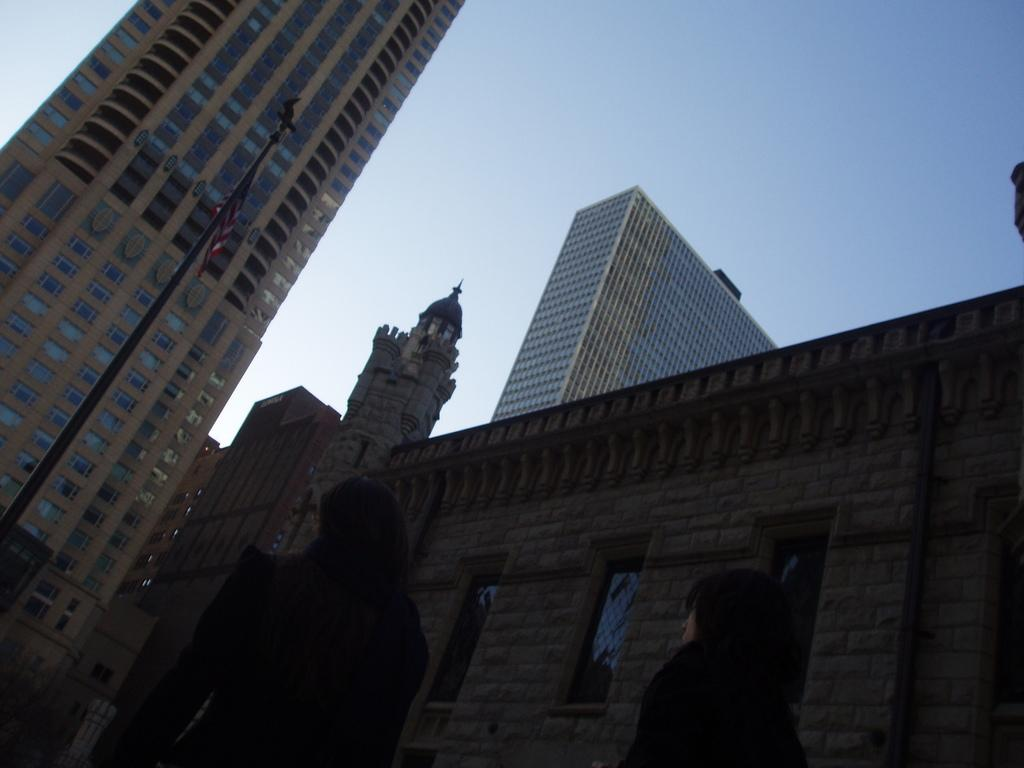What is the main subject of the image? The main subject of the image is the buildings in the center. Can you describe the buildings in the center? Unfortunately, the provided facts do not give any details about the buildings in the center. What other notable structure can be seen in the image? There is a skyscraper on the left side of the image. How many people are sitting on the yam in the image? There is no yam present in the image, so it is not possible to answer that question. 